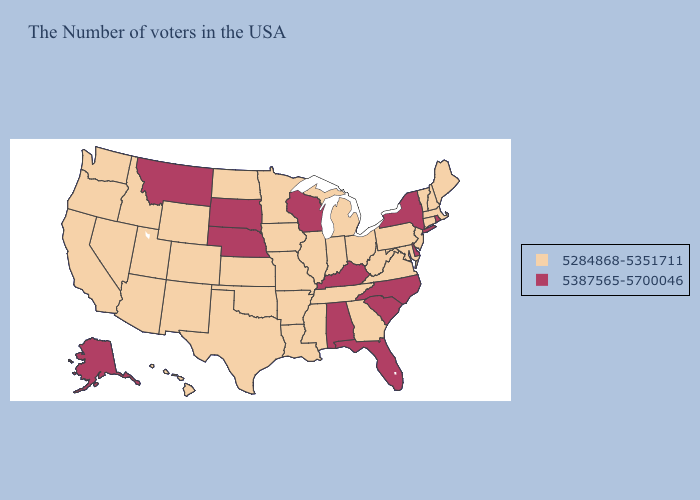What is the value of Minnesota?
Write a very short answer. 5284868-5351711. Name the states that have a value in the range 5387565-5700046?
Be succinct. Rhode Island, New York, Delaware, North Carolina, South Carolina, Florida, Kentucky, Alabama, Wisconsin, Nebraska, South Dakota, Montana, Alaska. Name the states that have a value in the range 5284868-5351711?
Short answer required. Maine, Massachusetts, New Hampshire, Vermont, Connecticut, New Jersey, Maryland, Pennsylvania, Virginia, West Virginia, Ohio, Georgia, Michigan, Indiana, Tennessee, Illinois, Mississippi, Louisiana, Missouri, Arkansas, Minnesota, Iowa, Kansas, Oklahoma, Texas, North Dakota, Wyoming, Colorado, New Mexico, Utah, Arizona, Idaho, Nevada, California, Washington, Oregon, Hawaii. Among the states that border Rhode Island , which have the lowest value?
Keep it brief. Massachusetts, Connecticut. Does Kansas have the highest value in the MidWest?
Write a very short answer. No. What is the value of Illinois?
Keep it brief. 5284868-5351711. Among the states that border Connecticut , does Rhode Island have the lowest value?
Quick response, please. No. Does Georgia have the lowest value in the USA?
Concise answer only. Yes. What is the value of Delaware?
Keep it brief. 5387565-5700046. Name the states that have a value in the range 5284868-5351711?
Concise answer only. Maine, Massachusetts, New Hampshire, Vermont, Connecticut, New Jersey, Maryland, Pennsylvania, Virginia, West Virginia, Ohio, Georgia, Michigan, Indiana, Tennessee, Illinois, Mississippi, Louisiana, Missouri, Arkansas, Minnesota, Iowa, Kansas, Oklahoma, Texas, North Dakota, Wyoming, Colorado, New Mexico, Utah, Arizona, Idaho, Nevada, California, Washington, Oregon, Hawaii. Name the states that have a value in the range 5284868-5351711?
Quick response, please. Maine, Massachusetts, New Hampshire, Vermont, Connecticut, New Jersey, Maryland, Pennsylvania, Virginia, West Virginia, Ohio, Georgia, Michigan, Indiana, Tennessee, Illinois, Mississippi, Louisiana, Missouri, Arkansas, Minnesota, Iowa, Kansas, Oklahoma, Texas, North Dakota, Wyoming, Colorado, New Mexico, Utah, Arizona, Idaho, Nevada, California, Washington, Oregon, Hawaii. What is the lowest value in states that border North Carolina?
Write a very short answer. 5284868-5351711. Name the states that have a value in the range 5284868-5351711?
Quick response, please. Maine, Massachusetts, New Hampshire, Vermont, Connecticut, New Jersey, Maryland, Pennsylvania, Virginia, West Virginia, Ohio, Georgia, Michigan, Indiana, Tennessee, Illinois, Mississippi, Louisiana, Missouri, Arkansas, Minnesota, Iowa, Kansas, Oklahoma, Texas, North Dakota, Wyoming, Colorado, New Mexico, Utah, Arizona, Idaho, Nevada, California, Washington, Oregon, Hawaii. 